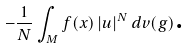<formula> <loc_0><loc_0><loc_500><loc_500>- \frac { 1 } { N } \int _ { M } f ( x ) \left | u \right | ^ { N } d v ( g ) \text {.}</formula> 